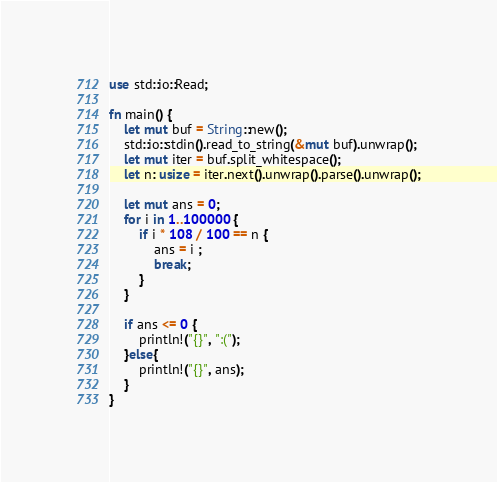Convert code to text. <code><loc_0><loc_0><loc_500><loc_500><_Rust_>use std::io::Read;

fn main() {
    let mut buf = String::new();
    std::io::stdin().read_to_string(&mut buf).unwrap();
    let mut iter = buf.split_whitespace();
    let n: usize = iter.next().unwrap().parse().unwrap();

    let mut ans = 0;
    for i in 1..100000 {
        if i * 108 / 100 == n {
            ans = i ;
            break;
        }
    }

    if ans <= 0 {
        println!("{}", ":(");
    }else{
        println!("{}", ans);
    }
}
</code> 